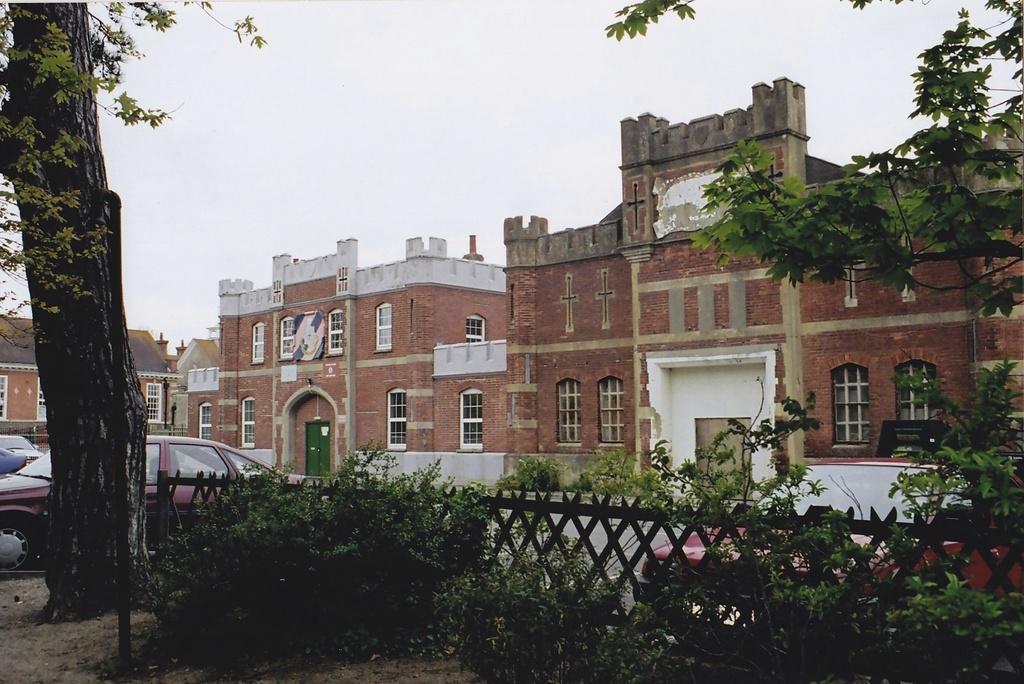How would you summarize this image in a sentence or two? In this picture I can see the fencing and the plants in front and I see few trees and I see the cars in front the fencing. In the background I see the buildings and the sky. 